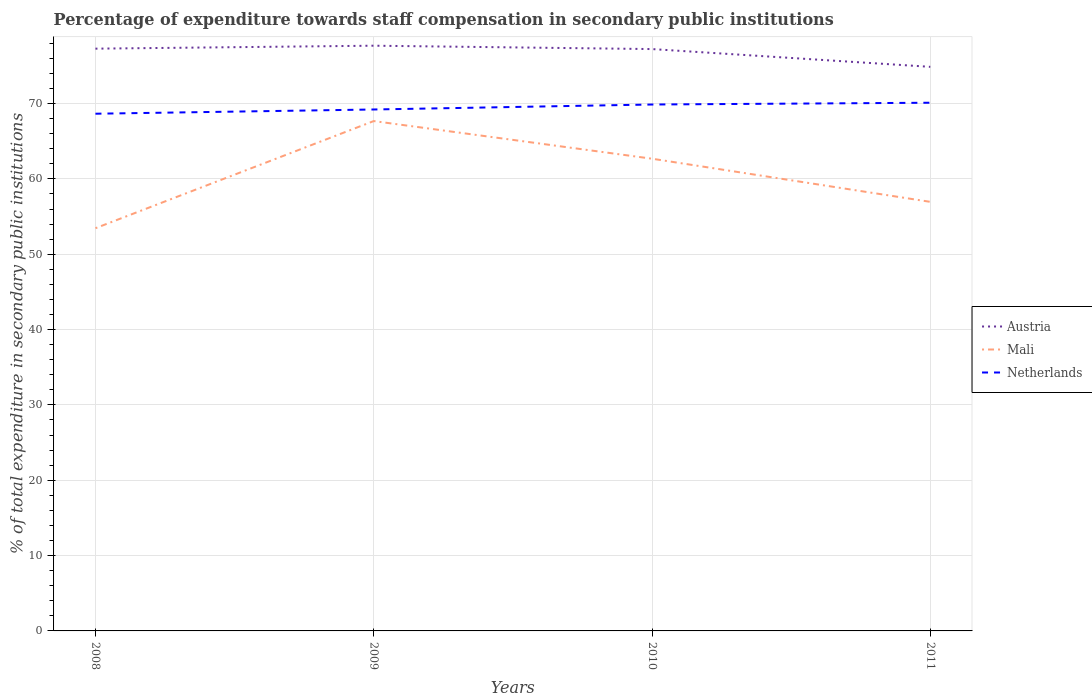How many different coloured lines are there?
Ensure brevity in your answer.  3. Across all years, what is the maximum percentage of expenditure towards staff compensation in Mali?
Give a very brief answer. 53.46. In which year was the percentage of expenditure towards staff compensation in Mali maximum?
Offer a very short reply. 2008. What is the total percentage of expenditure towards staff compensation in Austria in the graph?
Offer a very short reply. 2.41. What is the difference between the highest and the second highest percentage of expenditure towards staff compensation in Netherlands?
Give a very brief answer. 1.46. What is the difference between the highest and the lowest percentage of expenditure towards staff compensation in Mali?
Give a very brief answer. 2. How many years are there in the graph?
Keep it short and to the point. 4. What is the difference between two consecutive major ticks on the Y-axis?
Provide a short and direct response. 10. Does the graph contain any zero values?
Offer a very short reply. No. Does the graph contain grids?
Keep it short and to the point. Yes. How many legend labels are there?
Your answer should be very brief. 3. What is the title of the graph?
Offer a terse response. Percentage of expenditure towards staff compensation in secondary public institutions. Does "Dominican Republic" appear as one of the legend labels in the graph?
Provide a succinct answer. No. What is the label or title of the X-axis?
Provide a short and direct response. Years. What is the label or title of the Y-axis?
Your answer should be very brief. % of total expenditure in secondary public institutions. What is the % of total expenditure in secondary public institutions in Austria in 2008?
Provide a short and direct response. 77.29. What is the % of total expenditure in secondary public institutions of Mali in 2008?
Keep it short and to the point. 53.46. What is the % of total expenditure in secondary public institutions in Netherlands in 2008?
Give a very brief answer. 68.66. What is the % of total expenditure in secondary public institutions in Austria in 2009?
Your answer should be very brief. 77.68. What is the % of total expenditure in secondary public institutions of Mali in 2009?
Give a very brief answer. 67.68. What is the % of total expenditure in secondary public institutions in Netherlands in 2009?
Make the answer very short. 69.22. What is the % of total expenditure in secondary public institutions of Austria in 2010?
Keep it short and to the point. 77.24. What is the % of total expenditure in secondary public institutions of Mali in 2010?
Provide a succinct answer. 62.68. What is the % of total expenditure in secondary public institutions of Netherlands in 2010?
Your answer should be compact. 69.88. What is the % of total expenditure in secondary public institutions of Austria in 2011?
Provide a succinct answer. 74.88. What is the % of total expenditure in secondary public institutions in Mali in 2011?
Offer a very short reply. 56.96. What is the % of total expenditure in secondary public institutions of Netherlands in 2011?
Give a very brief answer. 70.11. Across all years, what is the maximum % of total expenditure in secondary public institutions of Austria?
Give a very brief answer. 77.68. Across all years, what is the maximum % of total expenditure in secondary public institutions in Mali?
Ensure brevity in your answer.  67.68. Across all years, what is the maximum % of total expenditure in secondary public institutions in Netherlands?
Your response must be concise. 70.11. Across all years, what is the minimum % of total expenditure in secondary public institutions of Austria?
Your response must be concise. 74.88. Across all years, what is the minimum % of total expenditure in secondary public institutions in Mali?
Your answer should be compact. 53.46. Across all years, what is the minimum % of total expenditure in secondary public institutions in Netherlands?
Ensure brevity in your answer.  68.66. What is the total % of total expenditure in secondary public institutions of Austria in the graph?
Make the answer very short. 307.09. What is the total % of total expenditure in secondary public institutions of Mali in the graph?
Provide a short and direct response. 240.78. What is the total % of total expenditure in secondary public institutions in Netherlands in the graph?
Provide a short and direct response. 277.86. What is the difference between the % of total expenditure in secondary public institutions in Austria in 2008 and that in 2009?
Your answer should be compact. -0.39. What is the difference between the % of total expenditure in secondary public institutions in Mali in 2008 and that in 2009?
Ensure brevity in your answer.  -14.22. What is the difference between the % of total expenditure in secondary public institutions in Netherlands in 2008 and that in 2009?
Keep it short and to the point. -0.56. What is the difference between the % of total expenditure in secondary public institutions of Austria in 2008 and that in 2010?
Keep it short and to the point. 0.06. What is the difference between the % of total expenditure in secondary public institutions of Mali in 2008 and that in 2010?
Make the answer very short. -9.23. What is the difference between the % of total expenditure in secondary public institutions in Netherlands in 2008 and that in 2010?
Your response must be concise. -1.22. What is the difference between the % of total expenditure in secondary public institutions of Austria in 2008 and that in 2011?
Your answer should be very brief. 2.41. What is the difference between the % of total expenditure in secondary public institutions of Mali in 2008 and that in 2011?
Keep it short and to the point. -3.5. What is the difference between the % of total expenditure in secondary public institutions of Netherlands in 2008 and that in 2011?
Your answer should be very brief. -1.46. What is the difference between the % of total expenditure in secondary public institutions in Austria in 2009 and that in 2010?
Your answer should be compact. 0.45. What is the difference between the % of total expenditure in secondary public institutions of Mali in 2009 and that in 2010?
Provide a short and direct response. 5. What is the difference between the % of total expenditure in secondary public institutions in Netherlands in 2009 and that in 2010?
Your response must be concise. -0.66. What is the difference between the % of total expenditure in secondary public institutions of Austria in 2009 and that in 2011?
Your answer should be very brief. 2.81. What is the difference between the % of total expenditure in secondary public institutions of Mali in 2009 and that in 2011?
Your response must be concise. 10.72. What is the difference between the % of total expenditure in secondary public institutions of Netherlands in 2009 and that in 2011?
Offer a terse response. -0.9. What is the difference between the % of total expenditure in secondary public institutions in Austria in 2010 and that in 2011?
Provide a short and direct response. 2.36. What is the difference between the % of total expenditure in secondary public institutions of Mali in 2010 and that in 2011?
Give a very brief answer. 5.73. What is the difference between the % of total expenditure in secondary public institutions in Netherlands in 2010 and that in 2011?
Your answer should be compact. -0.24. What is the difference between the % of total expenditure in secondary public institutions of Austria in 2008 and the % of total expenditure in secondary public institutions of Mali in 2009?
Offer a terse response. 9.61. What is the difference between the % of total expenditure in secondary public institutions in Austria in 2008 and the % of total expenditure in secondary public institutions in Netherlands in 2009?
Your answer should be very brief. 8.08. What is the difference between the % of total expenditure in secondary public institutions in Mali in 2008 and the % of total expenditure in secondary public institutions in Netherlands in 2009?
Offer a terse response. -15.76. What is the difference between the % of total expenditure in secondary public institutions in Austria in 2008 and the % of total expenditure in secondary public institutions in Mali in 2010?
Your answer should be compact. 14.61. What is the difference between the % of total expenditure in secondary public institutions of Austria in 2008 and the % of total expenditure in secondary public institutions of Netherlands in 2010?
Your response must be concise. 7.41. What is the difference between the % of total expenditure in secondary public institutions of Mali in 2008 and the % of total expenditure in secondary public institutions of Netherlands in 2010?
Keep it short and to the point. -16.42. What is the difference between the % of total expenditure in secondary public institutions in Austria in 2008 and the % of total expenditure in secondary public institutions in Mali in 2011?
Offer a very short reply. 20.33. What is the difference between the % of total expenditure in secondary public institutions in Austria in 2008 and the % of total expenditure in secondary public institutions in Netherlands in 2011?
Make the answer very short. 7.18. What is the difference between the % of total expenditure in secondary public institutions in Mali in 2008 and the % of total expenditure in secondary public institutions in Netherlands in 2011?
Make the answer very short. -16.66. What is the difference between the % of total expenditure in secondary public institutions of Austria in 2009 and the % of total expenditure in secondary public institutions of Mali in 2010?
Your answer should be very brief. 15. What is the difference between the % of total expenditure in secondary public institutions of Austria in 2009 and the % of total expenditure in secondary public institutions of Netherlands in 2010?
Give a very brief answer. 7.81. What is the difference between the % of total expenditure in secondary public institutions of Mali in 2009 and the % of total expenditure in secondary public institutions of Netherlands in 2010?
Give a very brief answer. -2.2. What is the difference between the % of total expenditure in secondary public institutions of Austria in 2009 and the % of total expenditure in secondary public institutions of Mali in 2011?
Ensure brevity in your answer.  20.73. What is the difference between the % of total expenditure in secondary public institutions in Austria in 2009 and the % of total expenditure in secondary public institutions in Netherlands in 2011?
Make the answer very short. 7.57. What is the difference between the % of total expenditure in secondary public institutions in Mali in 2009 and the % of total expenditure in secondary public institutions in Netherlands in 2011?
Ensure brevity in your answer.  -2.43. What is the difference between the % of total expenditure in secondary public institutions of Austria in 2010 and the % of total expenditure in secondary public institutions of Mali in 2011?
Give a very brief answer. 20.28. What is the difference between the % of total expenditure in secondary public institutions of Austria in 2010 and the % of total expenditure in secondary public institutions of Netherlands in 2011?
Keep it short and to the point. 7.12. What is the difference between the % of total expenditure in secondary public institutions in Mali in 2010 and the % of total expenditure in secondary public institutions in Netherlands in 2011?
Provide a succinct answer. -7.43. What is the average % of total expenditure in secondary public institutions of Austria per year?
Offer a very short reply. 76.77. What is the average % of total expenditure in secondary public institutions in Mali per year?
Offer a very short reply. 60.19. What is the average % of total expenditure in secondary public institutions of Netherlands per year?
Provide a succinct answer. 69.47. In the year 2008, what is the difference between the % of total expenditure in secondary public institutions in Austria and % of total expenditure in secondary public institutions in Mali?
Ensure brevity in your answer.  23.84. In the year 2008, what is the difference between the % of total expenditure in secondary public institutions of Austria and % of total expenditure in secondary public institutions of Netherlands?
Offer a very short reply. 8.64. In the year 2008, what is the difference between the % of total expenditure in secondary public institutions in Mali and % of total expenditure in secondary public institutions in Netherlands?
Your answer should be very brief. -15.2. In the year 2009, what is the difference between the % of total expenditure in secondary public institutions of Austria and % of total expenditure in secondary public institutions of Mali?
Provide a short and direct response. 10. In the year 2009, what is the difference between the % of total expenditure in secondary public institutions of Austria and % of total expenditure in secondary public institutions of Netherlands?
Give a very brief answer. 8.47. In the year 2009, what is the difference between the % of total expenditure in secondary public institutions of Mali and % of total expenditure in secondary public institutions of Netherlands?
Offer a very short reply. -1.54. In the year 2010, what is the difference between the % of total expenditure in secondary public institutions of Austria and % of total expenditure in secondary public institutions of Mali?
Keep it short and to the point. 14.55. In the year 2010, what is the difference between the % of total expenditure in secondary public institutions of Austria and % of total expenditure in secondary public institutions of Netherlands?
Your answer should be very brief. 7.36. In the year 2010, what is the difference between the % of total expenditure in secondary public institutions of Mali and % of total expenditure in secondary public institutions of Netherlands?
Provide a short and direct response. -7.2. In the year 2011, what is the difference between the % of total expenditure in secondary public institutions in Austria and % of total expenditure in secondary public institutions in Mali?
Your answer should be very brief. 17.92. In the year 2011, what is the difference between the % of total expenditure in secondary public institutions of Austria and % of total expenditure in secondary public institutions of Netherlands?
Your answer should be compact. 4.76. In the year 2011, what is the difference between the % of total expenditure in secondary public institutions of Mali and % of total expenditure in secondary public institutions of Netherlands?
Your response must be concise. -13.16. What is the ratio of the % of total expenditure in secondary public institutions of Mali in 2008 to that in 2009?
Make the answer very short. 0.79. What is the ratio of the % of total expenditure in secondary public institutions in Netherlands in 2008 to that in 2009?
Provide a succinct answer. 0.99. What is the ratio of the % of total expenditure in secondary public institutions in Austria in 2008 to that in 2010?
Provide a short and direct response. 1. What is the ratio of the % of total expenditure in secondary public institutions in Mali in 2008 to that in 2010?
Make the answer very short. 0.85. What is the ratio of the % of total expenditure in secondary public institutions in Netherlands in 2008 to that in 2010?
Offer a terse response. 0.98. What is the ratio of the % of total expenditure in secondary public institutions of Austria in 2008 to that in 2011?
Your answer should be compact. 1.03. What is the ratio of the % of total expenditure in secondary public institutions of Mali in 2008 to that in 2011?
Provide a succinct answer. 0.94. What is the ratio of the % of total expenditure in secondary public institutions of Netherlands in 2008 to that in 2011?
Your answer should be very brief. 0.98. What is the ratio of the % of total expenditure in secondary public institutions of Austria in 2009 to that in 2010?
Your response must be concise. 1.01. What is the ratio of the % of total expenditure in secondary public institutions of Mali in 2009 to that in 2010?
Your answer should be very brief. 1.08. What is the ratio of the % of total expenditure in secondary public institutions in Netherlands in 2009 to that in 2010?
Keep it short and to the point. 0.99. What is the ratio of the % of total expenditure in secondary public institutions in Austria in 2009 to that in 2011?
Your response must be concise. 1.04. What is the ratio of the % of total expenditure in secondary public institutions in Mali in 2009 to that in 2011?
Provide a succinct answer. 1.19. What is the ratio of the % of total expenditure in secondary public institutions of Netherlands in 2009 to that in 2011?
Your answer should be very brief. 0.99. What is the ratio of the % of total expenditure in secondary public institutions in Austria in 2010 to that in 2011?
Your answer should be compact. 1.03. What is the ratio of the % of total expenditure in secondary public institutions of Mali in 2010 to that in 2011?
Your response must be concise. 1.1. What is the ratio of the % of total expenditure in secondary public institutions of Netherlands in 2010 to that in 2011?
Offer a terse response. 1. What is the difference between the highest and the second highest % of total expenditure in secondary public institutions of Austria?
Offer a very short reply. 0.39. What is the difference between the highest and the second highest % of total expenditure in secondary public institutions of Mali?
Give a very brief answer. 5. What is the difference between the highest and the second highest % of total expenditure in secondary public institutions in Netherlands?
Offer a very short reply. 0.24. What is the difference between the highest and the lowest % of total expenditure in secondary public institutions of Austria?
Your answer should be very brief. 2.81. What is the difference between the highest and the lowest % of total expenditure in secondary public institutions in Mali?
Your answer should be compact. 14.22. What is the difference between the highest and the lowest % of total expenditure in secondary public institutions of Netherlands?
Offer a very short reply. 1.46. 